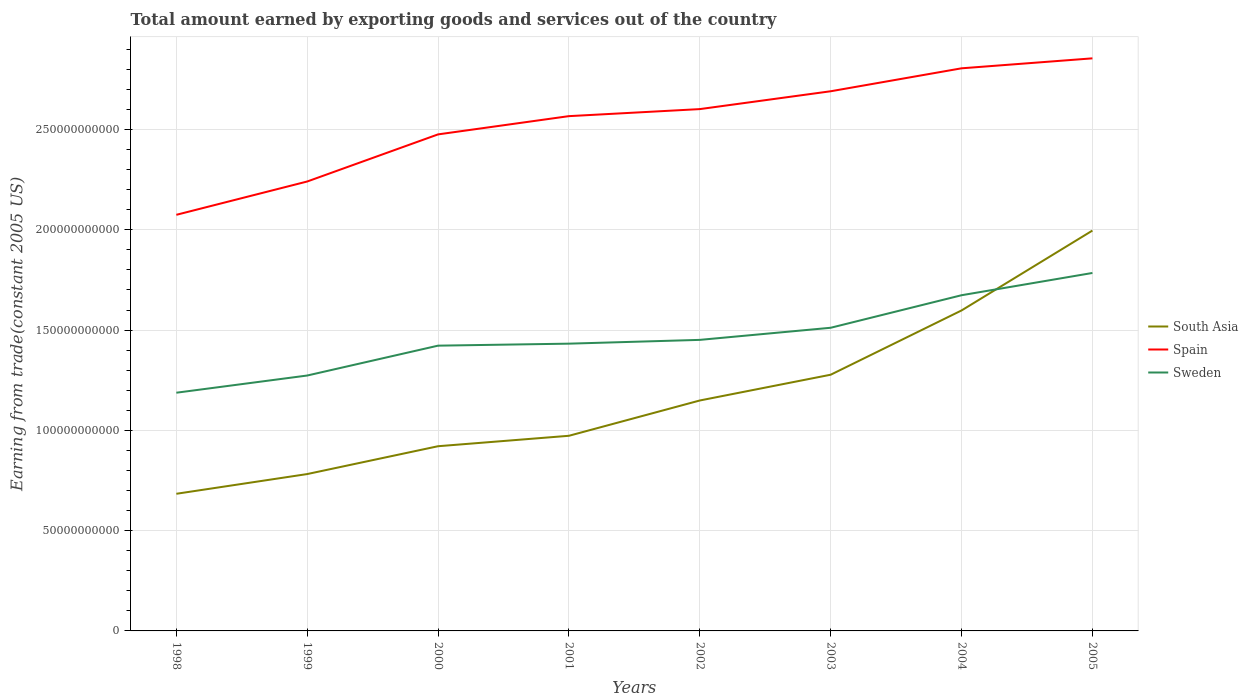Is the number of lines equal to the number of legend labels?
Keep it short and to the point. Yes. Across all years, what is the maximum total amount earned by exporting goods and services in Spain?
Provide a short and direct response. 2.07e+11. In which year was the total amount earned by exporting goods and services in Spain maximum?
Make the answer very short. 1998. What is the total total amount earned by exporting goods and services in Spain in the graph?
Your answer should be very brief. -3.79e+1. What is the difference between the highest and the second highest total amount earned by exporting goods and services in Sweden?
Your response must be concise. 5.97e+1. What is the difference between the highest and the lowest total amount earned by exporting goods and services in South Asia?
Give a very brief answer. 3. Is the total amount earned by exporting goods and services in Sweden strictly greater than the total amount earned by exporting goods and services in Spain over the years?
Your answer should be compact. Yes. Are the values on the major ticks of Y-axis written in scientific E-notation?
Make the answer very short. No. Where does the legend appear in the graph?
Provide a short and direct response. Center right. What is the title of the graph?
Provide a short and direct response. Total amount earned by exporting goods and services out of the country. What is the label or title of the Y-axis?
Provide a short and direct response. Earning from trade(constant 2005 US). What is the Earning from trade(constant 2005 US) of South Asia in 1998?
Your response must be concise. 6.84e+1. What is the Earning from trade(constant 2005 US) in Spain in 1998?
Offer a very short reply. 2.07e+11. What is the Earning from trade(constant 2005 US) in Sweden in 1998?
Offer a very short reply. 1.19e+11. What is the Earning from trade(constant 2005 US) in South Asia in 1999?
Offer a very short reply. 7.82e+1. What is the Earning from trade(constant 2005 US) in Spain in 1999?
Provide a succinct answer. 2.24e+11. What is the Earning from trade(constant 2005 US) of Sweden in 1999?
Keep it short and to the point. 1.27e+11. What is the Earning from trade(constant 2005 US) of South Asia in 2000?
Make the answer very short. 9.21e+1. What is the Earning from trade(constant 2005 US) in Spain in 2000?
Provide a short and direct response. 2.48e+11. What is the Earning from trade(constant 2005 US) of Sweden in 2000?
Your answer should be compact. 1.42e+11. What is the Earning from trade(constant 2005 US) of South Asia in 2001?
Offer a very short reply. 9.73e+1. What is the Earning from trade(constant 2005 US) in Spain in 2001?
Ensure brevity in your answer.  2.57e+11. What is the Earning from trade(constant 2005 US) in Sweden in 2001?
Make the answer very short. 1.43e+11. What is the Earning from trade(constant 2005 US) in South Asia in 2002?
Make the answer very short. 1.15e+11. What is the Earning from trade(constant 2005 US) of Spain in 2002?
Offer a very short reply. 2.60e+11. What is the Earning from trade(constant 2005 US) in Sweden in 2002?
Give a very brief answer. 1.45e+11. What is the Earning from trade(constant 2005 US) of South Asia in 2003?
Ensure brevity in your answer.  1.28e+11. What is the Earning from trade(constant 2005 US) in Spain in 2003?
Provide a succinct answer. 2.69e+11. What is the Earning from trade(constant 2005 US) of Sweden in 2003?
Offer a very short reply. 1.51e+11. What is the Earning from trade(constant 2005 US) in South Asia in 2004?
Your answer should be compact. 1.60e+11. What is the Earning from trade(constant 2005 US) of Spain in 2004?
Ensure brevity in your answer.  2.81e+11. What is the Earning from trade(constant 2005 US) of Sweden in 2004?
Make the answer very short. 1.67e+11. What is the Earning from trade(constant 2005 US) of South Asia in 2005?
Ensure brevity in your answer.  2.00e+11. What is the Earning from trade(constant 2005 US) of Spain in 2005?
Make the answer very short. 2.85e+11. What is the Earning from trade(constant 2005 US) in Sweden in 2005?
Give a very brief answer. 1.78e+11. Across all years, what is the maximum Earning from trade(constant 2005 US) in South Asia?
Offer a very short reply. 2.00e+11. Across all years, what is the maximum Earning from trade(constant 2005 US) of Spain?
Your answer should be compact. 2.85e+11. Across all years, what is the maximum Earning from trade(constant 2005 US) of Sweden?
Keep it short and to the point. 1.78e+11. Across all years, what is the minimum Earning from trade(constant 2005 US) of South Asia?
Your answer should be very brief. 6.84e+1. Across all years, what is the minimum Earning from trade(constant 2005 US) in Spain?
Offer a terse response. 2.07e+11. Across all years, what is the minimum Earning from trade(constant 2005 US) of Sweden?
Make the answer very short. 1.19e+11. What is the total Earning from trade(constant 2005 US) in South Asia in the graph?
Your answer should be compact. 9.38e+11. What is the total Earning from trade(constant 2005 US) of Spain in the graph?
Keep it short and to the point. 2.03e+12. What is the total Earning from trade(constant 2005 US) of Sweden in the graph?
Keep it short and to the point. 1.17e+12. What is the difference between the Earning from trade(constant 2005 US) in South Asia in 1998 and that in 1999?
Your answer should be compact. -9.83e+09. What is the difference between the Earning from trade(constant 2005 US) in Spain in 1998 and that in 1999?
Provide a short and direct response. -1.66e+1. What is the difference between the Earning from trade(constant 2005 US) of Sweden in 1998 and that in 1999?
Make the answer very short. -8.57e+09. What is the difference between the Earning from trade(constant 2005 US) in South Asia in 1998 and that in 2000?
Your response must be concise. -2.37e+1. What is the difference between the Earning from trade(constant 2005 US) in Spain in 1998 and that in 2000?
Your answer should be compact. -4.01e+1. What is the difference between the Earning from trade(constant 2005 US) of Sweden in 1998 and that in 2000?
Offer a very short reply. -2.35e+1. What is the difference between the Earning from trade(constant 2005 US) in South Asia in 1998 and that in 2001?
Provide a short and direct response. -2.89e+1. What is the difference between the Earning from trade(constant 2005 US) in Spain in 1998 and that in 2001?
Your answer should be compact. -4.92e+1. What is the difference between the Earning from trade(constant 2005 US) of Sweden in 1998 and that in 2001?
Your answer should be very brief. -2.45e+1. What is the difference between the Earning from trade(constant 2005 US) of South Asia in 1998 and that in 2002?
Make the answer very short. -4.65e+1. What is the difference between the Earning from trade(constant 2005 US) of Spain in 1998 and that in 2002?
Provide a succinct answer. -5.27e+1. What is the difference between the Earning from trade(constant 2005 US) of Sweden in 1998 and that in 2002?
Offer a terse response. -2.63e+1. What is the difference between the Earning from trade(constant 2005 US) of South Asia in 1998 and that in 2003?
Provide a succinct answer. -5.94e+1. What is the difference between the Earning from trade(constant 2005 US) in Spain in 1998 and that in 2003?
Ensure brevity in your answer.  -6.16e+1. What is the difference between the Earning from trade(constant 2005 US) in Sweden in 1998 and that in 2003?
Your answer should be compact. -3.24e+1. What is the difference between the Earning from trade(constant 2005 US) in South Asia in 1998 and that in 2004?
Provide a succinct answer. -9.14e+1. What is the difference between the Earning from trade(constant 2005 US) of Spain in 1998 and that in 2004?
Provide a succinct answer. -7.30e+1. What is the difference between the Earning from trade(constant 2005 US) in Sweden in 1998 and that in 2004?
Keep it short and to the point. -4.86e+1. What is the difference between the Earning from trade(constant 2005 US) in South Asia in 1998 and that in 2005?
Provide a short and direct response. -1.31e+11. What is the difference between the Earning from trade(constant 2005 US) of Spain in 1998 and that in 2005?
Offer a terse response. -7.80e+1. What is the difference between the Earning from trade(constant 2005 US) in Sweden in 1998 and that in 2005?
Your response must be concise. -5.97e+1. What is the difference between the Earning from trade(constant 2005 US) of South Asia in 1999 and that in 2000?
Provide a succinct answer. -1.39e+1. What is the difference between the Earning from trade(constant 2005 US) of Spain in 1999 and that in 2000?
Give a very brief answer. -2.35e+1. What is the difference between the Earning from trade(constant 2005 US) of Sweden in 1999 and that in 2000?
Offer a very short reply. -1.49e+1. What is the difference between the Earning from trade(constant 2005 US) of South Asia in 1999 and that in 2001?
Ensure brevity in your answer.  -1.91e+1. What is the difference between the Earning from trade(constant 2005 US) of Spain in 1999 and that in 2001?
Ensure brevity in your answer.  -3.26e+1. What is the difference between the Earning from trade(constant 2005 US) in Sweden in 1999 and that in 2001?
Your answer should be very brief. -1.59e+1. What is the difference between the Earning from trade(constant 2005 US) of South Asia in 1999 and that in 2002?
Make the answer very short. -3.67e+1. What is the difference between the Earning from trade(constant 2005 US) of Spain in 1999 and that in 2002?
Your answer should be compact. -3.61e+1. What is the difference between the Earning from trade(constant 2005 US) in Sweden in 1999 and that in 2002?
Offer a very short reply. -1.78e+1. What is the difference between the Earning from trade(constant 2005 US) of South Asia in 1999 and that in 2003?
Your answer should be very brief. -4.95e+1. What is the difference between the Earning from trade(constant 2005 US) of Spain in 1999 and that in 2003?
Offer a very short reply. -4.50e+1. What is the difference between the Earning from trade(constant 2005 US) in Sweden in 1999 and that in 2003?
Your response must be concise. -2.38e+1. What is the difference between the Earning from trade(constant 2005 US) in South Asia in 1999 and that in 2004?
Provide a short and direct response. -8.16e+1. What is the difference between the Earning from trade(constant 2005 US) of Spain in 1999 and that in 2004?
Your answer should be compact. -5.64e+1. What is the difference between the Earning from trade(constant 2005 US) in Sweden in 1999 and that in 2004?
Ensure brevity in your answer.  -4.00e+1. What is the difference between the Earning from trade(constant 2005 US) in South Asia in 1999 and that in 2005?
Offer a terse response. -1.21e+11. What is the difference between the Earning from trade(constant 2005 US) in Spain in 1999 and that in 2005?
Ensure brevity in your answer.  -6.14e+1. What is the difference between the Earning from trade(constant 2005 US) of Sweden in 1999 and that in 2005?
Offer a terse response. -5.11e+1. What is the difference between the Earning from trade(constant 2005 US) in South Asia in 2000 and that in 2001?
Make the answer very short. -5.20e+09. What is the difference between the Earning from trade(constant 2005 US) of Spain in 2000 and that in 2001?
Your answer should be very brief. -9.10e+09. What is the difference between the Earning from trade(constant 2005 US) in Sweden in 2000 and that in 2001?
Keep it short and to the point. -9.91e+08. What is the difference between the Earning from trade(constant 2005 US) in South Asia in 2000 and that in 2002?
Provide a short and direct response. -2.28e+1. What is the difference between the Earning from trade(constant 2005 US) of Spain in 2000 and that in 2002?
Your answer should be compact. -1.26e+1. What is the difference between the Earning from trade(constant 2005 US) of Sweden in 2000 and that in 2002?
Your answer should be very brief. -2.88e+09. What is the difference between the Earning from trade(constant 2005 US) in South Asia in 2000 and that in 2003?
Your response must be concise. -3.56e+1. What is the difference between the Earning from trade(constant 2005 US) in Spain in 2000 and that in 2003?
Give a very brief answer. -2.15e+1. What is the difference between the Earning from trade(constant 2005 US) in Sweden in 2000 and that in 2003?
Provide a succinct answer. -8.92e+09. What is the difference between the Earning from trade(constant 2005 US) of South Asia in 2000 and that in 2004?
Ensure brevity in your answer.  -6.77e+1. What is the difference between the Earning from trade(constant 2005 US) in Spain in 2000 and that in 2004?
Offer a very short reply. -3.29e+1. What is the difference between the Earning from trade(constant 2005 US) in Sweden in 2000 and that in 2004?
Offer a very short reply. -2.51e+1. What is the difference between the Earning from trade(constant 2005 US) of South Asia in 2000 and that in 2005?
Give a very brief answer. -1.08e+11. What is the difference between the Earning from trade(constant 2005 US) in Spain in 2000 and that in 2005?
Ensure brevity in your answer.  -3.79e+1. What is the difference between the Earning from trade(constant 2005 US) in Sweden in 2000 and that in 2005?
Provide a succinct answer. -3.62e+1. What is the difference between the Earning from trade(constant 2005 US) of South Asia in 2001 and that in 2002?
Offer a terse response. -1.76e+1. What is the difference between the Earning from trade(constant 2005 US) in Spain in 2001 and that in 2002?
Ensure brevity in your answer.  -3.51e+09. What is the difference between the Earning from trade(constant 2005 US) of Sweden in 2001 and that in 2002?
Provide a succinct answer. -1.89e+09. What is the difference between the Earning from trade(constant 2005 US) of South Asia in 2001 and that in 2003?
Your answer should be compact. -3.04e+1. What is the difference between the Earning from trade(constant 2005 US) in Spain in 2001 and that in 2003?
Your answer should be compact. -1.24e+1. What is the difference between the Earning from trade(constant 2005 US) in Sweden in 2001 and that in 2003?
Make the answer very short. -7.92e+09. What is the difference between the Earning from trade(constant 2005 US) of South Asia in 2001 and that in 2004?
Keep it short and to the point. -6.25e+1. What is the difference between the Earning from trade(constant 2005 US) in Spain in 2001 and that in 2004?
Your response must be concise. -2.38e+1. What is the difference between the Earning from trade(constant 2005 US) of Sweden in 2001 and that in 2004?
Give a very brief answer. -2.41e+1. What is the difference between the Earning from trade(constant 2005 US) of South Asia in 2001 and that in 2005?
Your answer should be compact. -1.02e+11. What is the difference between the Earning from trade(constant 2005 US) of Spain in 2001 and that in 2005?
Offer a very short reply. -2.88e+1. What is the difference between the Earning from trade(constant 2005 US) in Sweden in 2001 and that in 2005?
Ensure brevity in your answer.  -3.52e+1. What is the difference between the Earning from trade(constant 2005 US) in South Asia in 2002 and that in 2003?
Make the answer very short. -1.28e+1. What is the difference between the Earning from trade(constant 2005 US) of Spain in 2002 and that in 2003?
Make the answer very short. -8.90e+09. What is the difference between the Earning from trade(constant 2005 US) in Sweden in 2002 and that in 2003?
Offer a very short reply. -6.04e+09. What is the difference between the Earning from trade(constant 2005 US) in South Asia in 2002 and that in 2004?
Your answer should be compact. -4.49e+1. What is the difference between the Earning from trade(constant 2005 US) in Spain in 2002 and that in 2004?
Your answer should be very brief. -2.03e+1. What is the difference between the Earning from trade(constant 2005 US) of Sweden in 2002 and that in 2004?
Your answer should be compact. -2.23e+1. What is the difference between the Earning from trade(constant 2005 US) of South Asia in 2002 and that in 2005?
Your answer should be very brief. -8.47e+1. What is the difference between the Earning from trade(constant 2005 US) of Spain in 2002 and that in 2005?
Your response must be concise. -2.53e+1. What is the difference between the Earning from trade(constant 2005 US) of Sweden in 2002 and that in 2005?
Your response must be concise. -3.34e+1. What is the difference between the Earning from trade(constant 2005 US) in South Asia in 2003 and that in 2004?
Provide a short and direct response. -3.20e+1. What is the difference between the Earning from trade(constant 2005 US) in Spain in 2003 and that in 2004?
Keep it short and to the point. -1.14e+1. What is the difference between the Earning from trade(constant 2005 US) in Sweden in 2003 and that in 2004?
Offer a very short reply. -1.62e+1. What is the difference between the Earning from trade(constant 2005 US) in South Asia in 2003 and that in 2005?
Your answer should be very brief. -7.19e+1. What is the difference between the Earning from trade(constant 2005 US) in Spain in 2003 and that in 2005?
Your answer should be very brief. -1.64e+1. What is the difference between the Earning from trade(constant 2005 US) in Sweden in 2003 and that in 2005?
Your answer should be very brief. -2.73e+1. What is the difference between the Earning from trade(constant 2005 US) of South Asia in 2004 and that in 2005?
Keep it short and to the point. -3.98e+1. What is the difference between the Earning from trade(constant 2005 US) of Spain in 2004 and that in 2005?
Your answer should be very brief. -4.97e+09. What is the difference between the Earning from trade(constant 2005 US) of Sweden in 2004 and that in 2005?
Ensure brevity in your answer.  -1.11e+1. What is the difference between the Earning from trade(constant 2005 US) of South Asia in 1998 and the Earning from trade(constant 2005 US) of Spain in 1999?
Offer a very short reply. -1.56e+11. What is the difference between the Earning from trade(constant 2005 US) in South Asia in 1998 and the Earning from trade(constant 2005 US) in Sweden in 1999?
Make the answer very short. -5.90e+1. What is the difference between the Earning from trade(constant 2005 US) in Spain in 1998 and the Earning from trade(constant 2005 US) in Sweden in 1999?
Provide a short and direct response. 8.01e+1. What is the difference between the Earning from trade(constant 2005 US) of South Asia in 1998 and the Earning from trade(constant 2005 US) of Spain in 2000?
Offer a terse response. -1.79e+11. What is the difference between the Earning from trade(constant 2005 US) in South Asia in 1998 and the Earning from trade(constant 2005 US) in Sweden in 2000?
Make the answer very short. -7.39e+1. What is the difference between the Earning from trade(constant 2005 US) in Spain in 1998 and the Earning from trade(constant 2005 US) in Sweden in 2000?
Offer a very short reply. 6.52e+1. What is the difference between the Earning from trade(constant 2005 US) in South Asia in 1998 and the Earning from trade(constant 2005 US) in Spain in 2001?
Make the answer very short. -1.88e+11. What is the difference between the Earning from trade(constant 2005 US) in South Asia in 1998 and the Earning from trade(constant 2005 US) in Sweden in 2001?
Your answer should be very brief. -7.48e+1. What is the difference between the Earning from trade(constant 2005 US) in Spain in 1998 and the Earning from trade(constant 2005 US) in Sweden in 2001?
Keep it short and to the point. 6.42e+1. What is the difference between the Earning from trade(constant 2005 US) in South Asia in 1998 and the Earning from trade(constant 2005 US) in Spain in 2002?
Your answer should be compact. -1.92e+11. What is the difference between the Earning from trade(constant 2005 US) in South Asia in 1998 and the Earning from trade(constant 2005 US) in Sweden in 2002?
Make the answer very short. -7.67e+1. What is the difference between the Earning from trade(constant 2005 US) in Spain in 1998 and the Earning from trade(constant 2005 US) in Sweden in 2002?
Your answer should be very brief. 6.24e+1. What is the difference between the Earning from trade(constant 2005 US) of South Asia in 1998 and the Earning from trade(constant 2005 US) of Spain in 2003?
Provide a short and direct response. -2.01e+11. What is the difference between the Earning from trade(constant 2005 US) of South Asia in 1998 and the Earning from trade(constant 2005 US) of Sweden in 2003?
Provide a succinct answer. -8.28e+1. What is the difference between the Earning from trade(constant 2005 US) in Spain in 1998 and the Earning from trade(constant 2005 US) in Sweden in 2003?
Offer a terse response. 5.63e+1. What is the difference between the Earning from trade(constant 2005 US) of South Asia in 1998 and the Earning from trade(constant 2005 US) of Spain in 2004?
Offer a terse response. -2.12e+11. What is the difference between the Earning from trade(constant 2005 US) in South Asia in 1998 and the Earning from trade(constant 2005 US) in Sweden in 2004?
Provide a succinct answer. -9.90e+1. What is the difference between the Earning from trade(constant 2005 US) of Spain in 1998 and the Earning from trade(constant 2005 US) of Sweden in 2004?
Offer a very short reply. 4.01e+1. What is the difference between the Earning from trade(constant 2005 US) in South Asia in 1998 and the Earning from trade(constant 2005 US) in Spain in 2005?
Offer a very short reply. -2.17e+11. What is the difference between the Earning from trade(constant 2005 US) of South Asia in 1998 and the Earning from trade(constant 2005 US) of Sweden in 2005?
Give a very brief answer. -1.10e+11. What is the difference between the Earning from trade(constant 2005 US) of Spain in 1998 and the Earning from trade(constant 2005 US) of Sweden in 2005?
Offer a very short reply. 2.90e+1. What is the difference between the Earning from trade(constant 2005 US) of South Asia in 1999 and the Earning from trade(constant 2005 US) of Spain in 2000?
Keep it short and to the point. -1.69e+11. What is the difference between the Earning from trade(constant 2005 US) in South Asia in 1999 and the Earning from trade(constant 2005 US) in Sweden in 2000?
Provide a short and direct response. -6.40e+1. What is the difference between the Earning from trade(constant 2005 US) in Spain in 1999 and the Earning from trade(constant 2005 US) in Sweden in 2000?
Provide a short and direct response. 8.18e+1. What is the difference between the Earning from trade(constant 2005 US) of South Asia in 1999 and the Earning from trade(constant 2005 US) of Spain in 2001?
Your response must be concise. -1.78e+11. What is the difference between the Earning from trade(constant 2005 US) of South Asia in 1999 and the Earning from trade(constant 2005 US) of Sweden in 2001?
Give a very brief answer. -6.50e+1. What is the difference between the Earning from trade(constant 2005 US) of Spain in 1999 and the Earning from trade(constant 2005 US) of Sweden in 2001?
Make the answer very short. 8.09e+1. What is the difference between the Earning from trade(constant 2005 US) in South Asia in 1999 and the Earning from trade(constant 2005 US) in Spain in 2002?
Provide a succinct answer. -1.82e+11. What is the difference between the Earning from trade(constant 2005 US) in South Asia in 1999 and the Earning from trade(constant 2005 US) in Sweden in 2002?
Ensure brevity in your answer.  -6.69e+1. What is the difference between the Earning from trade(constant 2005 US) of Spain in 1999 and the Earning from trade(constant 2005 US) of Sweden in 2002?
Your answer should be very brief. 7.90e+1. What is the difference between the Earning from trade(constant 2005 US) in South Asia in 1999 and the Earning from trade(constant 2005 US) in Spain in 2003?
Provide a short and direct response. -1.91e+11. What is the difference between the Earning from trade(constant 2005 US) in South Asia in 1999 and the Earning from trade(constant 2005 US) in Sweden in 2003?
Provide a succinct answer. -7.29e+1. What is the difference between the Earning from trade(constant 2005 US) of Spain in 1999 and the Earning from trade(constant 2005 US) of Sweden in 2003?
Offer a very short reply. 7.29e+1. What is the difference between the Earning from trade(constant 2005 US) of South Asia in 1999 and the Earning from trade(constant 2005 US) of Spain in 2004?
Provide a short and direct response. -2.02e+11. What is the difference between the Earning from trade(constant 2005 US) in South Asia in 1999 and the Earning from trade(constant 2005 US) in Sweden in 2004?
Your answer should be compact. -8.92e+1. What is the difference between the Earning from trade(constant 2005 US) in Spain in 1999 and the Earning from trade(constant 2005 US) in Sweden in 2004?
Make the answer very short. 5.67e+1. What is the difference between the Earning from trade(constant 2005 US) of South Asia in 1999 and the Earning from trade(constant 2005 US) of Spain in 2005?
Make the answer very short. -2.07e+11. What is the difference between the Earning from trade(constant 2005 US) in South Asia in 1999 and the Earning from trade(constant 2005 US) in Sweden in 2005?
Offer a terse response. -1.00e+11. What is the difference between the Earning from trade(constant 2005 US) of Spain in 1999 and the Earning from trade(constant 2005 US) of Sweden in 2005?
Keep it short and to the point. 4.56e+1. What is the difference between the Earning from trade(constant 2005 US) of South Asia in 2000 and the Earning from trade(constant 2005 US) of Spain in 2001?
Make the answer very short. -1.65e+11. What is the difference between the Earning from trade(constant 2005 US) in South Asia in 2000 and the Earning from trade(constant 2005 US) in Sweden in 2001?
Keep it short and to the point. -5.11e+1. What is the difference between the Earning from trade(constant 2005 US) of Spain in 2000 and the Earning from trade(constant 2005 US) of Sweden in 2001?
Your answer should be very brief. 1.04e+11. What is the difference between the Earning from trade(constant 2005 US) in South Asia in 2000 and the Earning from trade(constant 2005 US) in Spain in 2002?
Make the answer very short. -1.68e+11. What is the difference between the Earning from trade(constant 2005 US) of South Asia in 2000 and the Earning from trade(constant 2005 US) of Sweden in 2002?
Offer a very short reply. -5.30e+1. What is the difference between the Earning from trade(constant 2005 US) in Spain in 2000 and the Earning from trade(constant 2005 US) in Sweden in 2002?
Your answer should be very brief. 1.02e+11. What is the difference between the Earning from trade(constant 2005 US) of South Asia in 2000 and the Earning from trade(constant 2005 US) of Spain in 2003?
Give a very brief answer. -1.77e+11. What is the difference between the Earning from trade(constant 2005 US) in South Asia in 2000 and the Earning from trade(constant 2005 US) in Sweden in 2003?
Your answer should be very brief. -5.91e+1. What is the difference between the Earning from trade(constant 2005 US) of Spain in 2000 and the Earning from trade(constant 2005 US) of Sweden in 2003?
Provide a short and direct response. 9.64e+1. What is the difference between the Earning from trade(constant 2005 US) in South Asia in 2000 and the Earning from trade(constant 2005 US) in Spain in 2004?
Give a very brief answer. -1.88e+11. What is the difference between the Earning from trade(constant 2005 US) in South Asia in 2000 and the Earning from trade(constant 2005 US) in Sweden in 2004?
Your response must be concise. -7.53e+1. What is the difference between the Earning from trade(constant 2005 US) of Spain in 2000 and the Earning from trade(constant 2005 US) of Sweden in 2004?
Ensure brevity in your answer.  8.02e+1. What is the difference between the Earning from trade(constant 2005 US) of South Asia in 2000 and the Earning from trade(constant 2005 US) of Spain in 2005?
Make the answer very short. -1.93e+11. What is the difference between the Earning from trade(constant 2005 US) of South Asia in 2000 and the Earning from trade(constant 2005 US) of Sweden in 2005?
Offer a terse response. -8.64e+1. What is the difference between the Earning from trade(constant 2005 US) in Spain in 2000 and the Earning from trade(constant 2005 US) in Sweden in 2005?
Provide a short and direct response. 6.91e+1. What is the difference between the Earning from trade(constant 2005 US) in South Asia in 2001 and the Earning from trade(constant 2005 US) in Spain in 2002?
Offer a very short reply. -1.63e+11. What is the difference between the Earning from trade(constant 2005 US) in South Asia in 2001 and the Earning from trade(constant 2005 US) in Sweden in 2002?
Your response must be concise. -4.78e+1. What is the difference between the Earning from trade(constant 2005 US) in Spain in 2001 and the Earning from trade(constant 2005 US) in Sweden in 2002?
Offer a very short reply. 1.12e+11. What is the difference between the Earning from trade(constant 2005 US) of South Asia in 2001 and the Earning from trade(constant 2005 US) of Spain in 2003?
Your response must be concise. -1.72e+11. What is the difference between the Earning from trade(constant 2005 US) in South Asia in 2001 and the Earning from trade(constant 2005 US) in Sweden in 2003?
Offer a very short reply. -5.39e+1. What is the difference between the Earning from trade(constant 2005 US) in Spain in 2001 and the Earning from trade(constant 2005 US) in Sweden in 2003?
Keep it short and to the point. 1.06e+11. What is the difference between the Earning from trade(constant 2005 US) of South Asia in 2001 and the Earning from trade(constant 2005 US) of Spain in 2004?
Offer a very short reply. -1.83e+11. What is the difference between the Earning from trade(constant 2005 US) in South Asia in 2001 and the Earning from trade(constant 2005 US) in Sweden in 2004?
Offer a terse response. -7.01e+1. What is the difference between the Earning from trade(constant 2005 US) of Spain in 2001 and the Earning from trade(constant 2005 US) of Sweden in 2004?
Offer a terse response. 8.93e+1. What is the difference between the Earning from trade(constant 2005 US) of South Asia in 2001 and the Earning from trade(constant 2005 US) of Spain in 2005?
Offer a very short reply. -1.88e+11. What is the difference between the Earning from trade(constant 2005 US) in South Asia in 2001 and the Earning from trade(constant 2005 US) in Sweden in 2005?
Provide a short and direct response. -8.12e+1. What is the difference between the Earning from trade(constant 2005 US) of Spain in 2001 and the Earning from trade(constant 2005 US) of Sweden in 2005?
Ensure brevity in your answer.  7.82e+1. What is the difference between the Earning from trade(constant 2005 US) of South Asia in 2002 and the Earning from trade(constant 2005 US) of Spain in 2003?
Your answer should be very brief. -1.54e+11. What is the difference between the Earning from trade(constant 2005 US) of South Asia in 2002 and the Earning from trade(constant 2005 US) of Sweden in 2003?
Ensure brevity in your answer.  -3.63e+1. What is the difference between the Earning from trade(constant 2005 US) of Spain in 2002 and the Earning from trade(constant 2005 US) of Sweden in 2003?
Offer a terse response. 1.09e+11. What is the difference between the Earning from trade(constant 2005 US) of South Asia in 2002 and the Earning from trade(constant 2005 US) of Spain in 2004?
Ensure brevity in your answer.  -1.66e+11. What is the difference between the Earning from trade(constant 2005 US) in South Asia in 2002 and the Earning from trade(constant 2005 US) in Sweden in 2004?
Your response must be concise. -5.25e+1. What is the difference between the Earning from trade(constant 2005 US) of Spain in 2002 and the Earning from trade(constant 2005 US) of Sweden in 2004?
Keep it short and to the point. 9.28e+1. What is the difference between the Earning from trade(constant 2005 US) in South Asia in 2002 and the Earning from trade(constant 2005 US) in Spain in 2005?
Provide a short and direct response. -1.71e+11. What is the difference between the Earning from trade(constant 2005 US) of South Asia in 2002 and the Earning from trade(constant 2005 US) of Sweden in 2005?
Your response must be concise. -6.36e+1. What is the difference between the Earning from trade(constant 2005 US) in Spain in 2002 and the Earning from trade(constant 2005 US) in Sweden in 2005?
Ensure brevity in your answer.  8.17e+1. What is the difference between the Earning from trade(constant 2005 US) of South Asia in 2003 and the Earning from trade(constant 2005 US) of Spain in 2004?
Provide a succinct answer. -1.53e+11. What is the difference between the Earning from trade(constant 2005 US) of South Asia in 2003 and the Earning from trade(constant 2005 US) of Sweden in 2004?
Offer a very short reply. -3.96e+1. What is the difference between the Earning from trade(constant 2005 US) of Spain in 2003 and the Earning from trade(constant 2005 US) of Sweden in 2004?
Make the answer very short. 1.02e+11. What is the difference between the Earning from trade(constant 2005 US) of South Asia in 2003 and the Earning from trade(constant 2005 US) of Spain in 2005?
Provide a succinct answer. -1.58e+11. What is the difference between the Earning from trade(constant 2005 US) in South Asia in 2003 and the Earning from trade(constant 2005 US) in Sweden in 2005?
Provide a short and direct response. -5.07e+1. What is the difference between the Earning from trade(constant 2005 US) in Spain in 2003 and the Earning from trade(constant 2005 US) in Sweden in 2005?
Ensure brevity in your answer.  9.06e+1. What is the difference between the Earning from trade(constant 2005 US) in South Asia in 2004 and the Earning from trade(constant 2005 US) in Spain in 2005?
Your answer should be very brief. -1.26e+11. What is the difference between the Earning from trade(constant 2005 US) of South Asia in 2004 and the Earning from trade(constant 2005 US) of Sweden in 2005?
Give a very brief answer. -1.87e+1. What is the difference between the Earning from trade(constant 2005 US) of Spain in 2004 and the Earning from trade(constant 2005 US) of Sweden in 2005?
Offer a very short reply. 1.02e+11. What is the average Earning from trade(constant 2005 US) of South Asia per year?
Your answer should be compact. 1.17e+11. What is the average Earning from trade(constant 2005 US) of Spain per year?
Your answer should be compact. 2.54e+11. What is the average Earning from trade(constant 2005 US) of Sweden per year?
Make the answer very short. 1.47e+11. In the year 1998, what is the difference between the Earning from trade(constant 2005 US) in South Asia and Earning from trade(constant 2005 US) in Spain?
Your answer should be compact. -1.39e+11. In the year 1998, what is the difference between the Earning from trade(constant 2005 US) in South Asia and Earning from trade(constant 2005 US) in Sweden?
Your response must be concise. -5.04e+1. In the year 1998, what is the difference between the Earning from trade(constant 2005 US) of Spain and Earning from trade(constant 2005 US) of Sweden?
Offer a very short reply. 8.87e+1. In the year 1999, what is the difference between the Earning from trade(constant 2005 US) in South Asia and Earning from trade(constant 2005 US) in Spain?
Provide a short and direct response. -1.46e+11. In the year 1999, what is the difference between the Earning from trade(constant 2005 US) of South Asia and Earning from trade(constant 2005 US) of Sweden?
Offer a terse response. -4.91e+1. In the year 1999, what is the difference between the Earning from trade(constant 2005 US) of Spain and Earning from trade(constant 2005 US) of Sweden?
Give a very brief answer. 9.67e+1. In the year 2000, what is the difference between the Earning from trade(constant 2005 US) in South Asia and Earning from trade(constant 2005 US) in Spain?
Ensure brevity in your answer.  -1.55e+11. In the year 2000, what is the difference between the Earning from trade(constant 2005 US) of South Asia and Earning from trade(constant 2005 US) of Sweden?
Your response must be concise. -5.01e+1. In the year 2000, what is the difference between the Earning from trade(constant 2005 US) in Spain and Earning from trade(constant 2005 US) in Sweden?
Your answer should be very brief. 1.05e+11. In the year 2001, what is the difference between the Earning from trade(constant 2005 US) in South Asia and Earning from trade(constant 2005 US) in Spain?
Give a very brief answer. -1.59e+11. In the year 2001, what is the difference between the Earning from trade(constant 2005 US) in South Asia and Earning from trade(constant 2005 US) in Sweden?
Make the answer very short. -4.59e+1. In the year 2001, what is the difference between the Earning from trade(constant 2005 US) of Spain and Earning from trade(constant 2005 US) of Sweden?
Keep it short and to the point. 1.13e+11. In the year 2002, what is the difference between the Earning from trade(constant 2005 US) in South Asia and Earning from trade(constant 2005 US) in Spain?
Give a very brief answer. -1.45e+11. In the year 2002, what is the difference between the Earning from trade(constant 2005 US) of South Asia and Earning from trade(constant 2005 US) of Sweden?
Your answer should be very brief. -3.02e+1. In the year 2002, what is the difference between the Earning from trade(constant 2005 US) of Spain and Earning from trade(constant 2005 US) of Sweden?
Offer a very short reply. 1.15e+11. In the year 2003, what is the difference between the Earning from trade(constant 2005 US) in South Asia and Earning from trade(constant 2005 US) in Spain?
Keep it short and to the point. -1.41e+11. In the year 2003, what is the difference between the Earning from trade(constant 2005 US) of South Asia and Earning from trade(constant 2005 US) of Sweden?
Provide a succinct answer. -2.34e+1. In the year 2003, what is the difference between the Earning from trade(constant 2005 US) in Spain and Earning from trade(constant 2005 US) in Sweden?
Give a very brief answer. 1.18e+11. In the year 2004, what is the difference between the Earning from trade(constant 2005 US) of South Asia and Earning from trade(constant 2005 US) of Spain?
Your answer should be compact. -1.21e+11. In the year 2004, what is the difference between the Earning from trade(constant 2005 US) of South Asia and Earning from trade(constant 2005 US) of Sweden?
Offer a very short reply. -7.59e+09. In the year 2004, what is the difference between the Earning from trade(constant 2005 US) in Spain and Earning from trade(constant 2005 US) in Sweden?
Ensure brevity in your answer.  1.13e+11. In the year 2005, what is the difference between the Earning from trade(constant 2005 US) in South Asia and Earning from trade(constant 2005 US) in Spain?
Offer a terse response. -8.59e+1. In the year 2005, what is the difference between the Earning from trade(constant 2005 US) of South Asia and Earning from trade(constant 2005 US) of Sweden?
Keep it short and to the point. 2.11e+1. In the year 2005, what is the difference between the Earning from trade(constant 2005 US) of Spain and Earning from trade(constant 2005 US) of Sweden?
Provide a short and direct response. 1.07e+11. What is the ratio of the Earning from trade(constant 2005 US) in South Asia in 1998 to that in 1999?
Make the answer very short. 0.87. What is the ratio of the Earning from trade(constant 2005 US) of Spain in 1998 to that in 1999?
Offer a very short reply. 0.93. What is the ratio of the Earning from trade(constant 2005 US) in Sweden in 1998 to that in 1999?
Your answer should be very brief. 0.93. What is the ratio of the Earning from trade(constant 2005 US) of South Asia in 1998 to that in 2000?
Keep it short and to the point. 0.74. What is the ratio of the Earning from trade(constant 2005 US) in Spain in 1998 to that in 2000?
Your answer should be very brief. 0.84. What is the ratio of the Earning from trade(constant 2005 US) in Sweden in 1998 to that in 2000?
Give a very brief answer. 0.83. What is the ratio of the Earning from trade(constant 2005 US) of South Asia in 1998 to that in 2001?
Provide a succinct answer. 0.7. What is the ratio of the Earning from trade(constant 2005 US) in Spain in 1998 to that in 2001?
Your answer should be very brief. 0.81. What is the ratio of the Earning from trade(constant 2005 US) in Sweden in 1998 to that in 2001?
Your response must be concise. 0.83. What is the ratio of the Earning from trade(constant 2005 US) in South Asia in 1998 to that in 2002?
Give a very brief answer. 0.6. What is the ratio of the Earning from trade(constant 2005 US) in Spain in 1998 to that in 2002?
Make the answer very short. 0.8. What is the ratio of the Earning from trade(constant 2005 US) of Sweden in 1998 to that in 2002?
Give a very brief answer. 0.82. What is the ratio of the Earning from trade(constant 2005 US) in South Asia in 1998 to that in 2003?
Provide a succinct answer. 0.54. What is the ratio of the Earning from trade(constant 2005 US) of Spain in 1998 to that in 2003?
Provide a succinct answer. 0.77. What is the ratio of the Earning from trade(constant 2005 US) in Sweden in 1998 to that in 2003?
Your response must be concise. 0.79. What is the ratio of the Earning from trade(constant 2005 US) in South Asia in 1998 to that in 2004?
Give a very brief answer. 0.43. What is the ratio of the Earning from trade(constant 2005 US) in Spain in 1998 to that in 2004?
Keep it short and to the point. 0.74. What is the ratio of the Earning from trade(constant 2005 US) in Sweden in 1998 to that in 2004?
Offer a very short reply. 0.71. What is the ratio of the Earning from trade(constant 2005 US) of South Asia in 1998 to that in 2005?
Keep it short and to the point. 0.34. What is the ratio of the Earning from trade(constant 2005 US) in Spain in 1998 to that in 2005?
Offer a very short reply. 0.73. What is the ratio of the Earning from trade(constant 2005 US) in Sweden in 1998 to that in 2005?
Give a very brief answer. 0.67. What is the ratio of the Earning from trade(constant 2005 US) in South Asia in 1999 to that in 2000?
Your response must be concise. 0.85. What is the ratio of the Earning from trade(constant 2005 US) of Spain in 1999 to that in 2000?
Your answer should be very brief. 0.91. What is the ratio of the Earning from trade(constant 2005 US) of Sweden in 1999 to that in 2000?
Keep it short and to the point. 0.9. What is the ratio of the Earning from trade(constant 2005 US) in South Asia in 1999 to that in 2001?
Offer a terse response. 0.8. What is the ratio of the Earning from trade(constant 2005 US) of Spain in 1999 to that in 2001?
Provide a succinct answer. 0.87. What is the ratio of the Earning from trade(constant 2005 US) in Sweden in 1999 to that in 2001?
Provide a short and direct response. 0.89. What is the ratio of the Earning from trade(constant 2005 US) of South Asia in 1999 to that in 2002?
Ensure brevity in your answer.  0.68. What is the ratio of the Earning from trade(constant 2005 US) in Spain in 1999 to that in 2002?
Offer a very short reply. 0.86. What is the ratio of the Earning from trade(constant 2005 US) in Sweden in 1999 to that in 2002?
Your answer should be compact. 0.88. What is the ratio of the Earning from trade(constant 2005 US) of South Asia in 1999 to that in 2003?
Provide a short and direct response. 0.61. What is the ratio of the Earning from trade(constant 2005 US) in Spain in 1999 to that in 2003?
Make the answer very short. 0.83. What is the ratio of the Earning from trade(constant 2005 US) in Sweden in 1999 to that in 2003?
Give a very brief answer. 0.84. What is the ratio of the Earning from trade(constant 2005 US) in South Asia in 1999 to that in 2004?
Ensure brevity in your answer.  0.49. What is the ratio of the Earning from trade(constant 2005 US) in Spain in 1999 to that in 2004?
Give a very brief answer. 0.8. What is the ratio of the Earning from trade(constant 2005 US) in Sweden in 1999 to that in 2004?
Your answer should be very brief. 0.76. What is the ratio of the Earning from trade(constant 2005 US) in South Asia in 1999 to that in 2005?
Offer a terse response. 0.39. What is the ratio of the Earning from trade(constant 2005 US) in Spain in 1999 to that in 2005?
Keep it short and to the point. 0.78. What is the ratio of the Earning from trade(constant 2005 US) of Sweden in 1999 to that in 2005?
Make the answer very short. 0.71. What is the ratio of the Earning from trade(constant 2005 US) in South Asia in 2000 to that in 2001?
Offer a very short reply. 0.95. What is the ratio of the Earning from trade(constant 2005 US) in Spain in 2000 to that in 2001?
Your response must be concise. 0.96. What is the ratio of the Earning from trade(constant 2005 US) of Sweden in 2000 to that in 2001?
Your answer should be compact. 0.99. What is the ratio of the Earning from trade(constant 2005 US) in South Asia in 2000 to that in 2002?
Your answer should be compact. 0.8. What is the ratio of the Earning from trade(constant 2005 US) in Spain in 2000 to that in 2002?
Your answer should be compact. 0.95. What is the ratio of the Earning from trade(constant 2005 US) in Sweden in 2000 to that in 2002?
Give a very brief answer. 0.98. What is the ratio of the Earning from trade(constant 2005 US) of South Asia in 2000 to that in 2003?
Offer a very short reply. 0.72. What is the ratio of the Earning from trade(constant 2005 US) of Spain in 2000 to that in 2003?
Ensure brevity in your answer.  0.92. What is the ratio of the Earning from trade(constant 2005 US) of Sweden in 2000 to that in 2003?
Your answer should be very brief. 0.94. What is the ratio of the Earning from trade(constant 2005 US) in South Asia in 2000 to that in 2004?
Offer a very short reply. 0.58. What is the ratio of the Earning from trade(constant 2005 US) in Spain in 2000 to that in 2004?
Offer a terse response. 0.88. What is the ratio of the Earning from trade(constant 2005 US) in Sweden in 2000 to that in 2004?
Give a very brief answer. 0.85. What is the ratio of the Earning from trade(constant 2005 US) of South Asia in 2000 to that in 2005?
Your response must be concise. 0.46. What is the ratio of the Earning from trade(constant 2005 US) of Spain in 2000 to that in 2005?
Provide a short and direct response. 0.87. What is the ratio of the Earning from trade(constant 2005 US) of Sweden in 2000 to that in 2005?
Your answer should be compact. 0.8. What is the ratio of the Earning from trade(constant 2005 US) of South Asia in 2001 to that in 2002?
Keep it short and to the point. 0.85. What is the ratio of the Earning from trade(constant 2005 US) in Spain in 2001 to that in 2002?
Your response must be concise. 0.99. What is the ratio of the Earning from trade(constant 2005 US) in South Asia in 2001 to that in 2003?
Make the answer very short. 0.76. What is the ratio of the Earning from trade(constant 2005 US) of Spain in 2001 to that in 2003?
Provide a short and direct response. 0.95. What is the ratio of the Earning from trade(constant 2005 US) in Sweden in 2001 to that in 2003?
Your answer should be very brief. 0.95. What is the ratio of the Earning from trade(constant 2005 US) in South Asia in 2001 to that in 2004?
Offer a terse response. 0.61. What is the ratio of the Earning from trade(constant 2005 US) of Spain in 2001 to that in 2004?
Give a very brief answer. 0.92. What is the ratio of the Earning from trade(constant 2005 US) in Sweden in 2001 to that in 2004?
Offer a very short reply. 0.86. What is the ratio of the Earning from trade(constant 2005 US) of South Asia in 2001 to that in 2005?
Offer a very short reply. 0.49. What is the ratio of the Earning from trade(constant 2005 US) in Spain in 2001 to that in 2005?
Give a very brief answer. 0.9. What is the ratio of the Earning from trade(constant 2005 US) in Sweden in 2001 to that in 2005?
Your answer should be compact. 0.8. What is the ratio of the Earning from trade(constant 2005 US) in South Asia in 2002 to that in 2003?
Keep it short and to the point. 0.9. What is the ratio of the Earning from trade(constant 2005 US) of Spain in 2002 to that in 2003?
Provide a short and direct response. 0.97. What is the ratio of the Earning from trade(constant 2005 US) of Sweden in 2002 to that in 2003?
Provide a short and direct response. 0.96. What is the ratio of the Earning from trade(constant 2005 US) of South Asia in 2002 to that in 2004?
Give a very brief answer. 0.72. What is the ratio of the Earning from trade(constant 2005 US) in Spain in 2002 to that in 2004?
Make the answer very short. 0.93. What is the ratio of the Earning from trade(constant 2005 US) of Sweden in 2002 to that in 2004?
Your response must be concise. 0.87. What is the ratio of the Earning from trade(constant 2005 US) in South Asia in 2002 to that in 2005?
Give a very brief answer. 0.58. What is the ratio of the Earning from trade(constant 2005 US) of Spain in 2002 to that in 2005?
Provide a short and direct response. 0.91. What is the ratio of the Earning from trade(constant 2005 US) of Sweden in 2002 to that in 2005?
Offer a terse response. 0.81. What is the ratio of the Earning from trade(constant 2005 US) in South Asia in 2003 to that in 2004?
Provide a succinct answer. 0.8. What is the ratio of the Earning from trade(constant 2005 US) in Spain in 2003 to that in 2004?
Give a very brief answer. 0.96. What is the ratio of the Earning from trade(constant 2005 US) of Sweden in 2003 to that in 2004?
Your response must be concise. 0.9. What is the ratio of the Earning from trade(constant 2005 US) of South Asia in 2003 to that in 2005?
Offer a very short reply. 0.64. What is the ratio of the Earning from trade(constant 2005 US) of Spain in 2003 to that in 2005?
Offer a terse response. 0.94. What is the ratio of the Earning from trade(constant 2005 US) of Sweden in 2003 to that in 2005?
Your answer should be compact. 0.85. What is the ratio of the Earning from trade(constant 2005 US) in South Asia in 2004 to that in 2005?
Make the answer very short. 0.8. What is the ratio of the Earning from trade(constant 2005 US) of Spain in 2004 to that in 2005?
Give a very brief answer. 0.98. What is the ratio of the Earning from trade(constant 2005 US) of Sweden in 2004 to that in 2005?
Ensure brevity in your answer.  0.94. What is the difference between the highest and the second highest Earning from trade(constant 2005 US) of South Asia?
Offer a terse response. 3.98e+1. What is the difference between the highest and the second highest Earning from trade(constant 2005 US) in Spain?
Offer a terse response. 4.97e+09. What is the difference between the highest and the second highest Earning from trade(constant 2005 US) in Sweden?
Your answer should be very brief. 1.11e+1. What is the difference between the highest and the lowest Earning from trade(constant 2005 US) of South Asia?
Provide a short and direct response. 1.31e+11. What is the difference between the highest and the lowest Earning from trade(constant 2005 US) in Spain?
Give a very brief answer. 7.80e+1. What is the difference between the highest and the lowest Earning from trade(constant 2005 US) in Sweden?
Provide a short and direct response. 5.97e+1. 